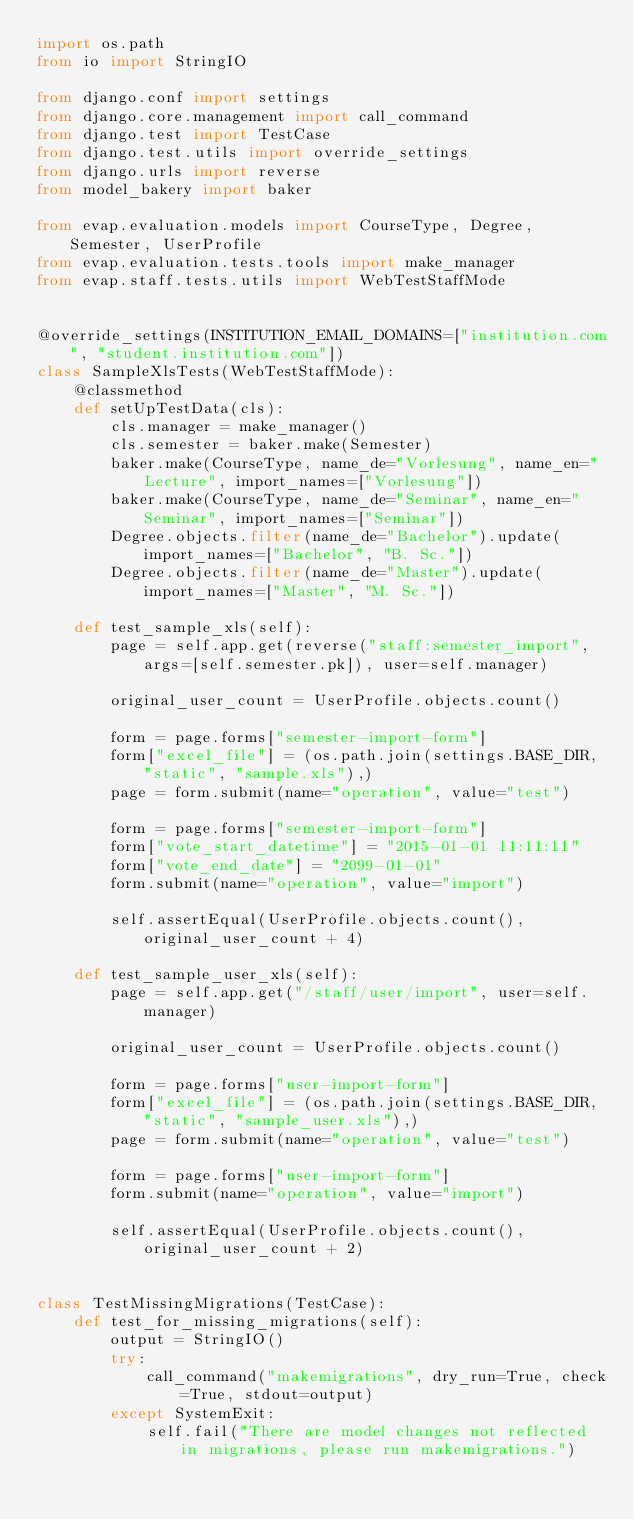Convert code to text. <code><loc_0><loc_0><loc_500><loc_500><_Python_>import os.path
from io import StringIO

from django.conf import settings
from django.core.management import call_command
from django.test import TestCase
from django.test.utils import override_settings
from django.urls import reverse
from model_bakery import baker

from evap.evaluation.models import CourseType, Degree, Semester, UserProfile
from evap.evaluation.tests.tools import make_manager
from evap.staff.tests.utils import WebTestStaffMode


@override_settings(INSTITUTION_EMAIL_DOMAINS=["institution.com", "student.institution.com"])
class SampleXlsTests(WebTestStaffMode):
    @classmethod
    def setUpTestData(cls):
        cls.manager = make_manager()
        cls.semester = baker.make(Semester)
        baker.make(CourseType, name_de="Vorlesung", name_en="Lecture", import_names=["Vorlesung"])
        baker.make(CourseType, name_de="Seminar", name_en="Seminar", import_names=["Seminar"])
        Degree.objects.filter(name_de="Bachelor").update(import_names=["Bachelor", "B. Sc."])
        Degree.objects.filter(name_de="Master").update(import_names=["Master", "M. Sc."])

    def test_sample_xls(self):
        page = self.app.get(reverse("staff:semester_import", args=[self.semester.pk]), user=self.manager)

        original_user_count = UserProfile.objects.count()

        form = page.forms["semester-import-form"]
        form["excel_file"] = (os.path.join(settings.BASE_DIR, "static", "sample.xls"),)
        page = form.submit(name="operation", value="test")

        form = page.forms["semester-import-form"]
        form["vote_start_datetime"] = "2015-01-01 11:11:11"
        form["vote_end_date"] = "2099-01-01"
        form.submit(name="operation", value="import")

        self.assertEqual(UserProfile.objects.count(), original_user_count + 4)

    def test_sample_user_xls(self):
        page = self.app.get("/staff/user/import", user=self.manager)

        original_user_count = UserProfile.objects.count()

        form = page.forms["user-import-form"]
        form["excel_file"] = (os.path.join(settings.BASE_DIR, "static", "sample_user.xls"),)
        page = form.submit(name="operation", value="test")

        form = page.forms["user-import-form"]
        form.submit(name="operation", value="import")

        self.assertEqual(UserProfile.objects.count(), original_user_count + 2)


class TestMissingMigrations(TestCase):
    def test_for_missing_migrations(self):
        output = StringIO()
        try:
            call_command("makemigrations", dry_run=True, check=True, stdout=output)
        except SystemExit:
            self.fail("There are model changes not reflected in migrations, please run makemigrations.")
</code> 